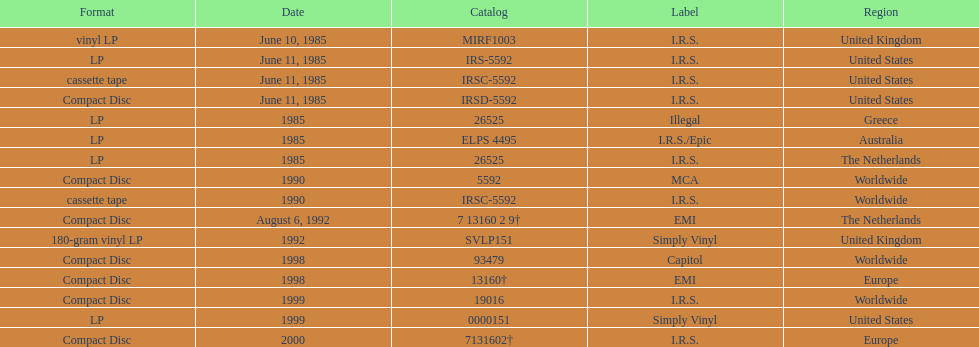Would you be able to parse every entry in this table? {'header': ['Format', 'Date', 'Catalog', 'Label', 'Region'], 'rows': [['vinyl LP', 'June 10, 1985', 'MIRF1003', 'I.R.S.', 'United Kingdom'], ['LP', 'June 11, 1985', 'IRS-5592', 'I.R.S.', 'United States'], ['cassette tape', 'June 11, 1985', 'IRSC-5592', 'I.R.S.', 'United States'], ['Compact Disc', 'June 11, 1985', 'IRSD-5592', 'I.R.S.', 'United States'], ['LP', '1985', '26525', 'Illegal', 'Greece'], ['LP', '1985', 'ELPS 4495', 'I.R.S./Epic', 'Australia'], ['LP', '1985', '26525', 'I.R.S.', 'The Netherlands'], ['Compact Disc', '1990', '5592', 'MCA', 'Worldwide'], ['cassette tape', '1990', 'IRSC-5592', 'I.R.S.', 'Worldwide'], ['Compact Disc', 'August 6, 1992', '7 13160 2 9†', 'EMI', 'The Netherlands'], ['180-gram vinyl LP', '1992', 'SVLP151', 'Simply Vinyl', 'United Kingdom'], ['Compact Disc', '1998', '93479', 'Capitol', 'Worldwide'], ['Compact Disc', '1998', '13160†', 'EMI', 'Europe'], ['Compact Disc', '1999', '19016', 'I.R.S.', 'Worldwide'], ['LP', '1999', '0000151', 'Simply Vinyl', 'United States'], ['Compact Disc', '2000', '7131602†', 'I.R.S.', 'Europe']]} Which region has more than one format? United States. 